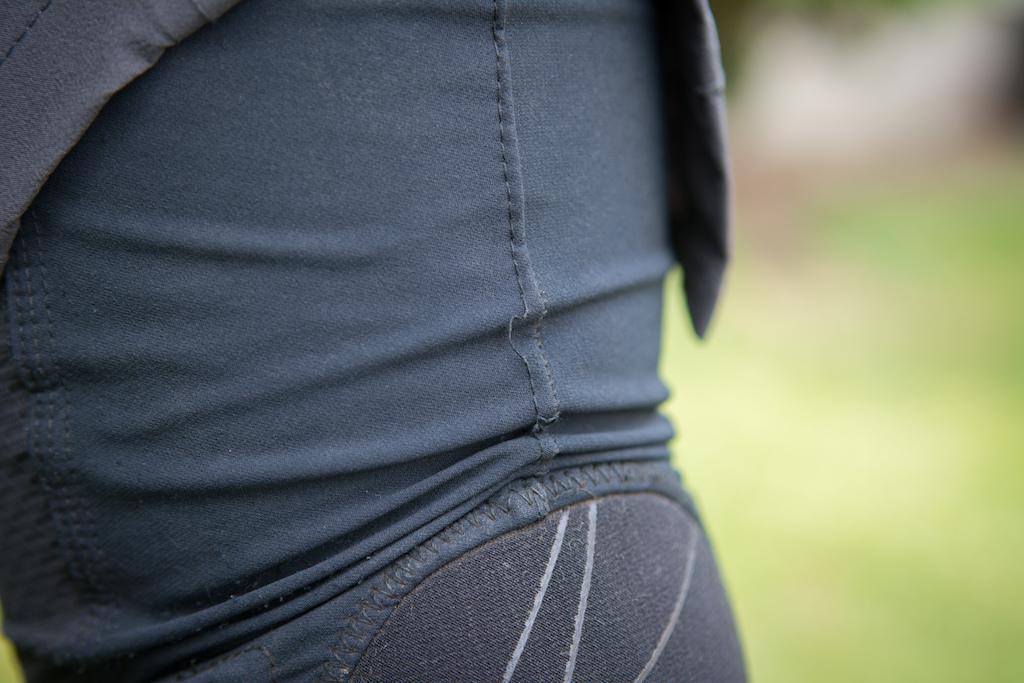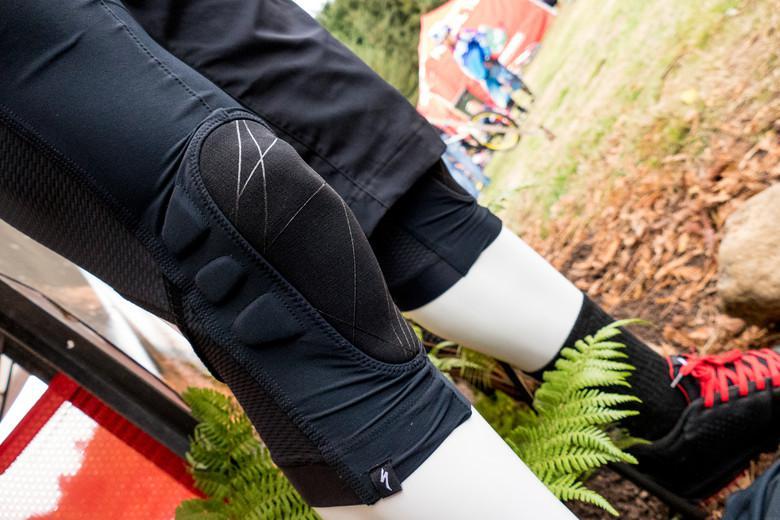The first image is the image on the left, the second image is the image on the right. Considering the images on both sides, is "Product is shown not on a body." valid? Answer yes or no. No. 